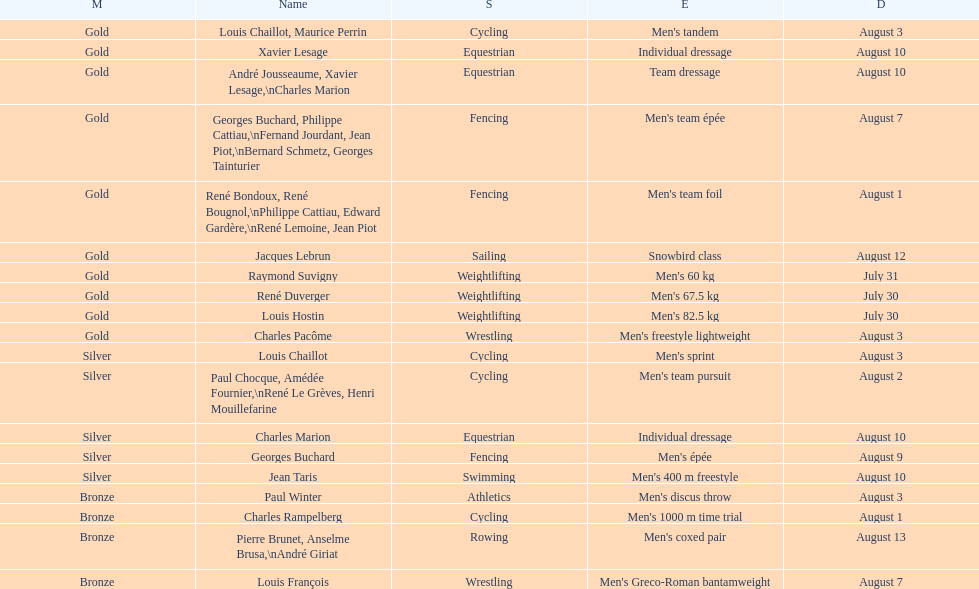What event is listed right before team dressage? Individual dressage. 